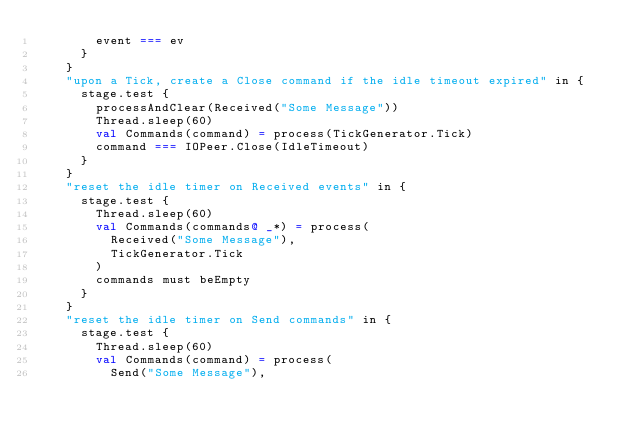<code> <loc_0><loc_0><loc_500><loc_500><_Scala_>        event === ev
      }
    }
    "upon a Tick, create a Close command if the idle timeout expired" in {
      stage.test {
        processAndClear(Received("Some Message"))
        Thread.sleep(60)
        val Commands(command) = process(TickGenerator.Tick)
        command === IOPeer.Close(IdleTimeout)
      }
    }
    "reset the idle timer on Received events" in {
      stage.test {
        Thread.sleep(60)
        val Commands(commands@ _*) = process(
          Received("Some Message"),
          TickGenerator.Tick
        )
        commands must beEmpty
      }
    }
    "reset the idle timer on Send commands" in {
      stage.test {
        Thread.sleep(60)
        val Commands(command) = process(
          Send("Some Message"),</code> 